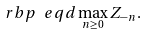Convert formula to latex. <formula><loc_0><loc_0><loc_500><loc_500>\ r b p \ e q d \max _ { n \geq 0 } Z _ { - n } .</formula> 